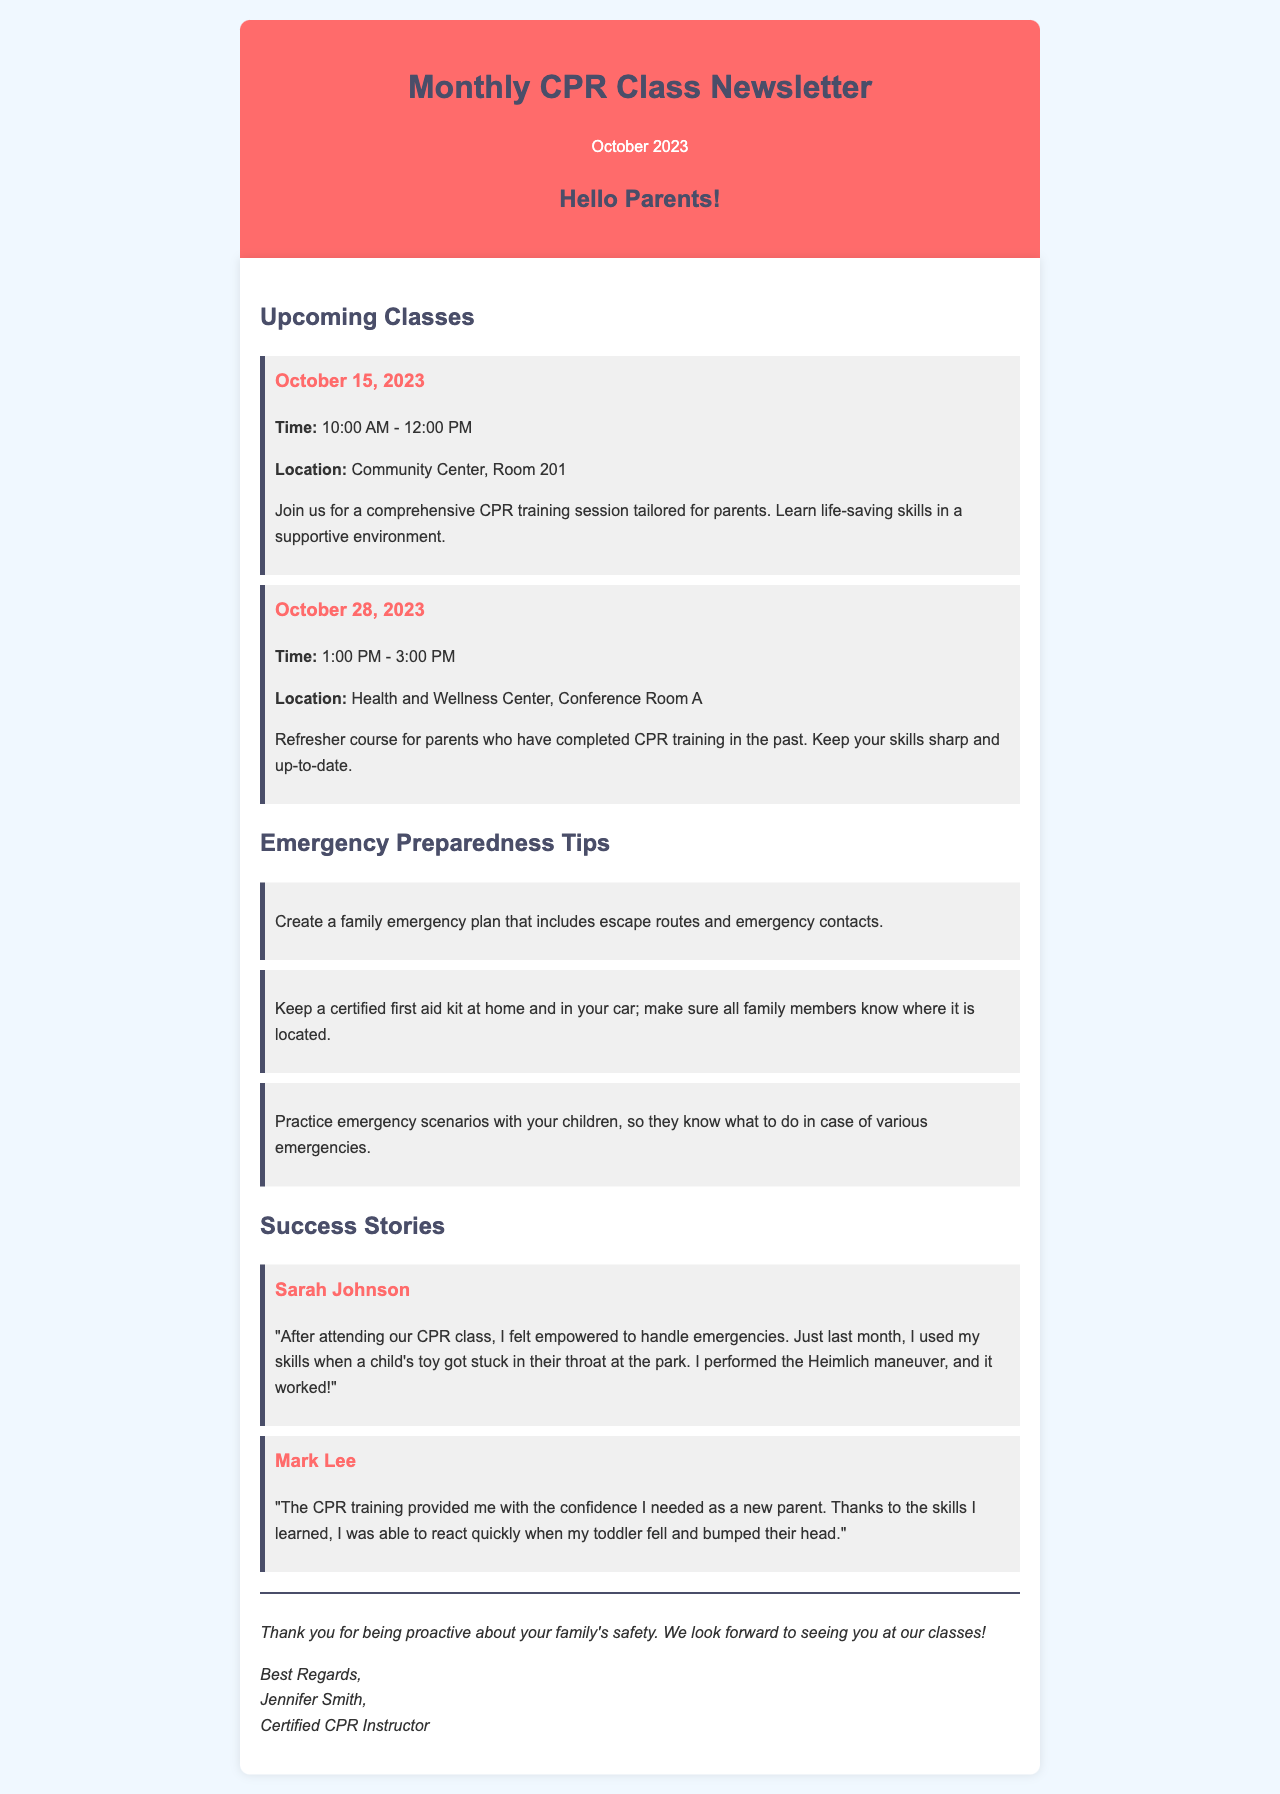What is the date of the first upcoming CPR class? The first upcoming CPR class is scheduled for October 15, 2023.
Answer: October 15, 2023 What time does the refresher course start? The refresher course starts at 1:00 PM on October 28, 2023.
Answer: 1:00 PM Where will the CPR training on October 15 be held? The CPR training on October 15 will be held at the Community Center, Room 201.
Answer: Community Center, Room 201 What is one emergency preparedness tip mentioned in the newsletter? One tip mentioned is to create a family emergency plan that includes escape routes and emergency contacts.
Answer: Create a family emergency plan How did Sarah Johnson use her CPR skills? Sarah Johnson used her CPR skills to perform the Heimlich maneuver on a child at the park.
Answer: Heimlich maneuver How many emergency preparedness tips are listed in the newsletter? There are three emergency preparedness tips listed in the newsletter.
Answer: Three Who is the author of the newsletter? The author of the newsletter is Jennifer Smith, Certified CPR Instructor.
Answer: Jennifer Smith What color is used in the header of the newsletter? The color used in the header of the newsletter is #ff6b6b (a shade of red).
Answer: #ff6b6b 